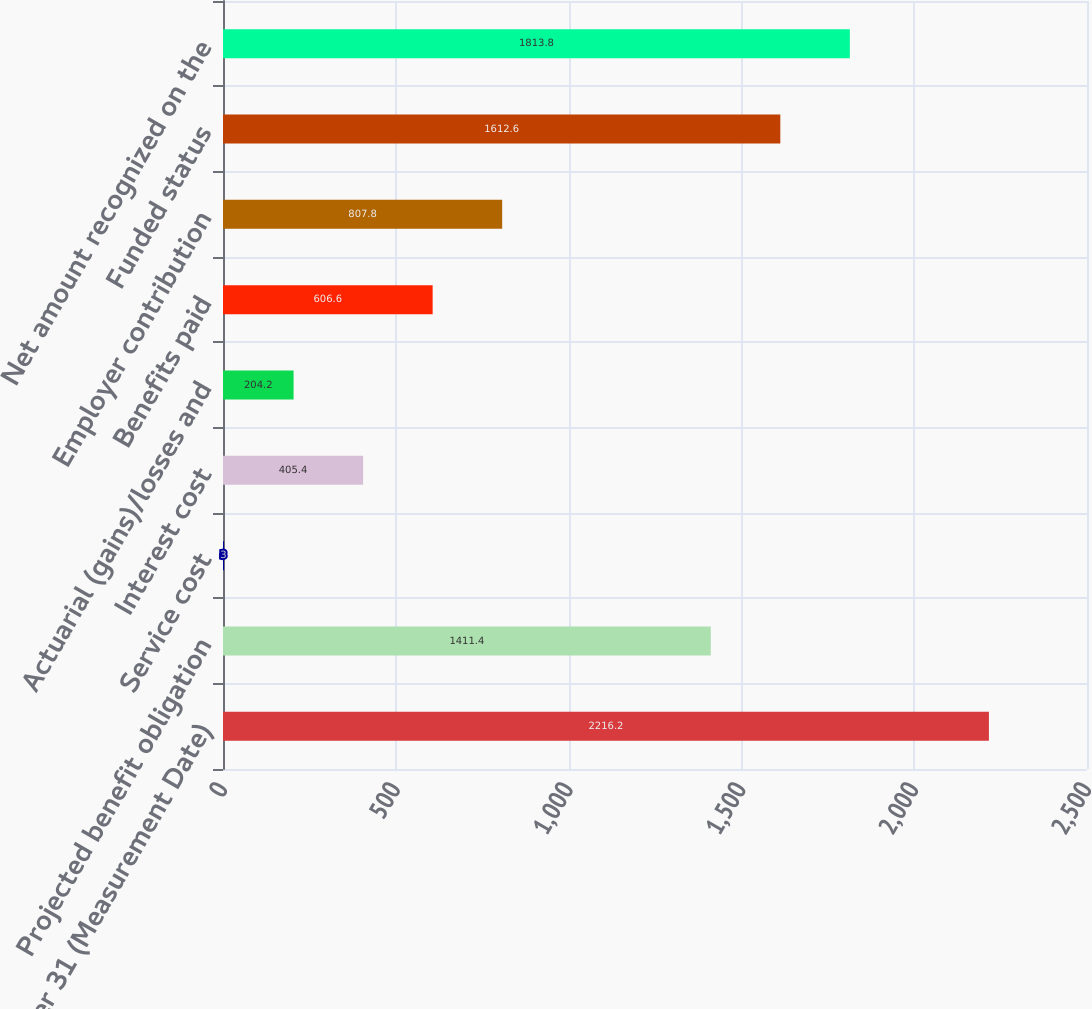Convert chart. <chart><loc_0><loc_0><loc_500><loc_500><bar_chart><fcel>December 31 (Measurement Date)<fcel>Projected benefit obligation<fcel>Service cost<fcel>Interest cost<fcel>Actuarial (gains)/losses and<fcel>Benefits paid<fcel>Employer contribution<fcel>Funded status<fcel>Net amount recognized on the<nl><fcel>2216.2<fcel>1411.4<fcel>3<fcel>405.4<fcel>204.2<fcel>606.6<fcel>807.8<fcel>1612.6<fcel>1813.8<nl></chart> 